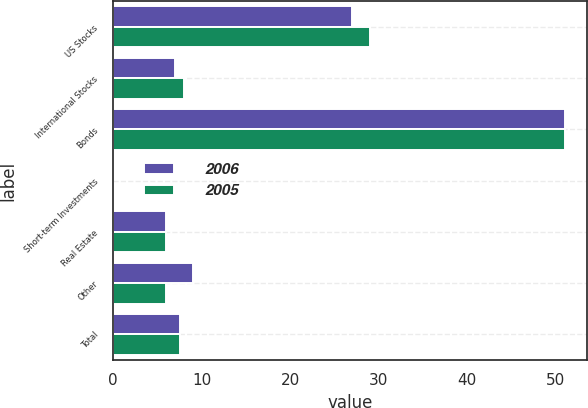Convert chart. <chart><loc_0><loc_0><loc_500><loc_500><stacked_bar_chart><ecel><fcel>US Stocks<fcel>International Stocks<fcel>Bonds<fcel>Short-term Investments<fcel>Real Estate<fcel>Other<fcel>Total<nl><fcel>2006<fcel>27<fcel>7<fcel>51<fcel>0<fcel>6<fcel>9<fcel>7.5<nl><fcel>2005<fcel>29<fcel>8<fcel>51<fcel>0<fcel>6<fcel>6<fcel>7.5<nl></chart> 